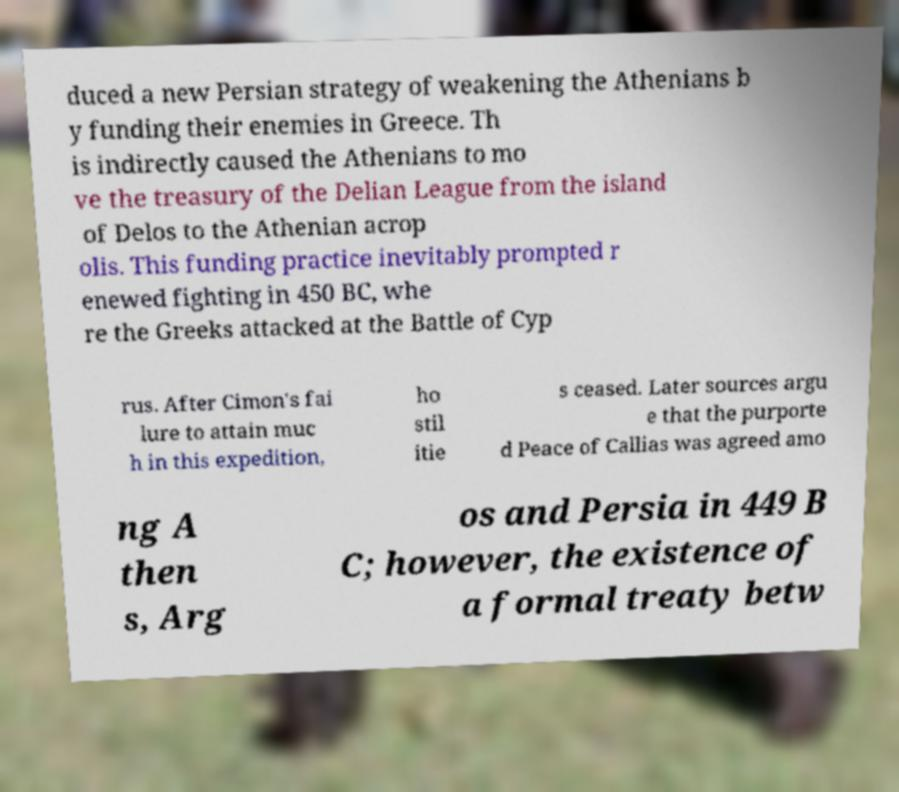Please identify and transcribe the text found in this image. duced a new Persian strategy of weakening the Athenians b y funding their enemies in Greece. Th is indirectly caused the Athenians to mo ve the treasury of the Delian League from the island of Delos to the Athenian acrop olis. This funding practice inevitably prompted r enewed fighting in 450 BC, whe re the Greeks attacked at the Battle of Cyp rus. After Cimon's fai lure to attain muc h in this expedition, ho stil itie s ceased. Later sources argu e that the purporte d Peace of Callias was agreed amo ng A then s, Arg os and Persia in 449 B C; however, the existence of a formal treaty betw 